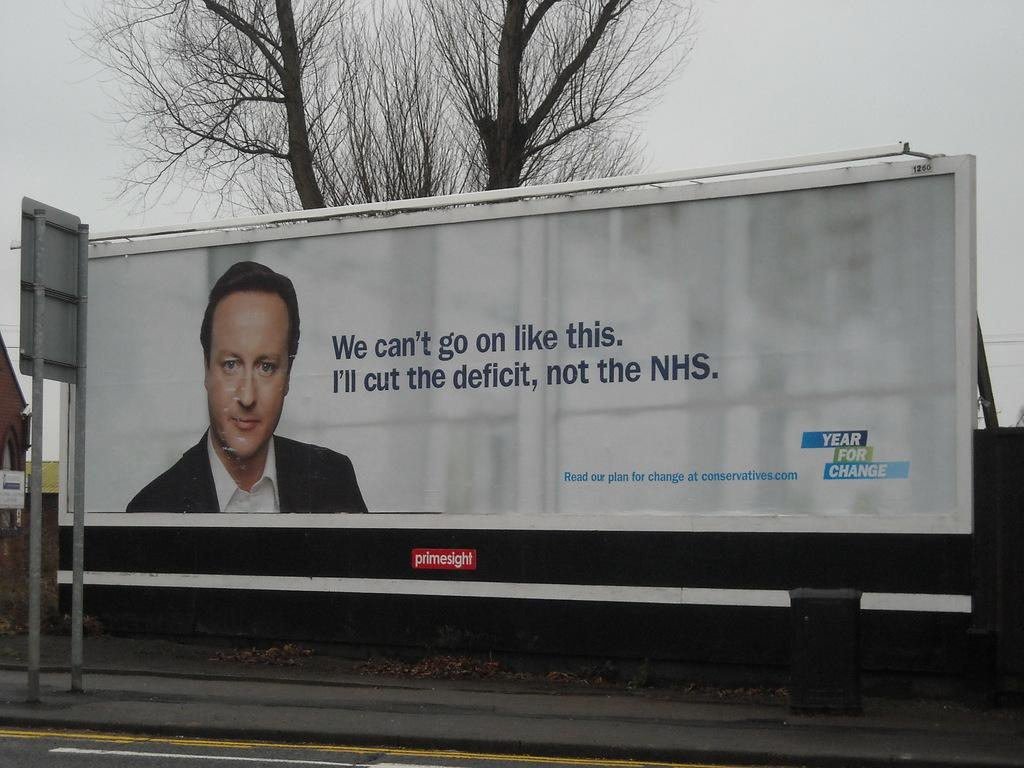What is the main object in the image? There is a board in the image. What is depicted on the board? A person's face is visible on the board. What is the person wearing in the image? The person is wearing a black blazer and a white shirt. What can be seen in the background of the image? There are dried trees and the sky visible in the background. What is the color of the sky in the image? The sky is white in color. What type of plough is being used to cultivate the field in the image? There is no field or plough present in the image; it features a board with a person's face and a background with dried trees and a white sky. How does the person on the board look at the camera? The image is a still representation, so the person's facial expression is fixed and cannot be described as looking at the camera. 